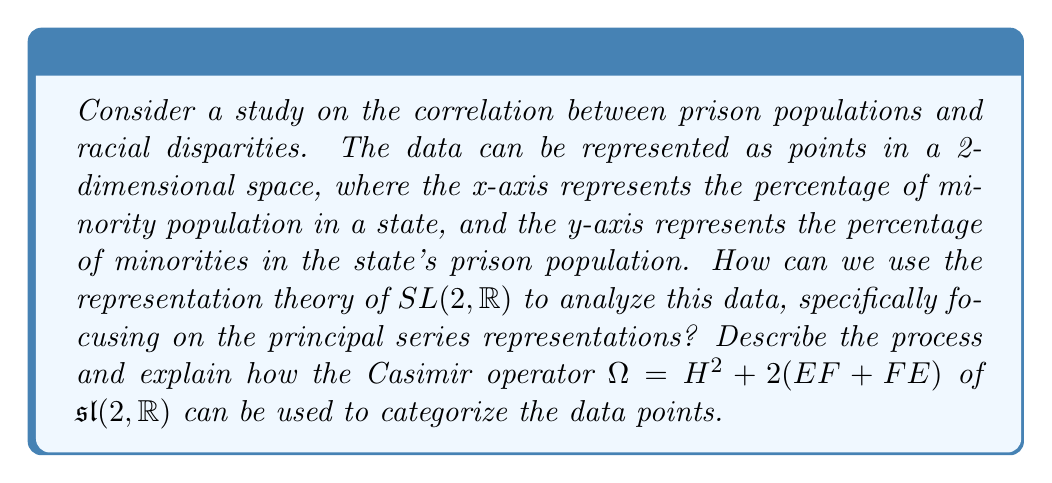Can you solve this math problem? To analyze this socioeconomic data using the representation theory of $SL(2,\mathbb{R})$, we can follow these steps:

1) First, we need to understand that $SL(2,\mathbb{R})$ acts on the upper half-plane model of hyperbolic space $\mathbb{H}^2 = \{z \in \mathbb{C} : \text{Im}(z) > 0\}$ via Möbius transformations:

   $$\begin{pmatrix} a & b \\ c & d \end{pmatrix} \cdot z = \frac{az + b}{cz + d}$$

2) We can map our data points $(x, y)$ to the upper half-plane using the transformation:

   $$z = x + iy$$

3) The principal series representations of $SL(2,\mathbb{R})$ are parameterized by a complex number $s$. For each $s \in \mathbb{C}$, we have a representation $\pi_s$ acting on functions on the real line as:

   $$(\pi_s(g)f)(x) = |cx+d|^{-2s}f(\frac{ax+b}{cx+d})$$

   where $g = \begin{pmatrix} a & b \\ c & d \end{pmatrix} \in SL(2,\mathbb{R})$.

4) The Casimir operator $\Omega = H^2 + 2(EF + FE)$ acts on these representations as a scalar multiple of the identity:

   $$\Omega = s(1-s)I$$

5) To categorize our data points, we can associate each point with a value of $s$. One way to do this is to use the hyperbolic distance $d(z,i)$ from the point $z$ to $i$ in the upper half-plane:

   $$s = \frac{1}{2} + ir, \text{ where } r = \frac{d(z,i)}{2}$$

6) The hyperbolic distance can be calculated using:

   $$d(z,i) = \text{arcosh}(1 + \frac{|z-i|^2}{2\text{Im}(z)})$$

7) Now, for each data point, we have an associated $s$ value, which determines a principal series representation. The Casimir operator eigenvalue $s(1-s)$ for this representation gives us a way to categorize the data points.

8) Points with similar $s$ values (and thus similar Casimir eigenvalues) can be grouped together, potentially revealing patterns in the socioeconomic data.

This approach allows us to use the rich structure of $SL(2,\mathbb{R})$ representations to analyze and categorize our socioeconomic data in a mathematically sophisticated way.
Answer: The process to analyze the data using $SL(2,\mathbb{R})$ representation theory involves:
1) Mapping data points to the upper half-plane
2) Associating each point with a principal series representation parameterized by $s = \frac{1}{2} + ir$
3) Calculating $r$ using the hyperbolic distance: $r = \frac{1}{2}\text{arcosh}(1 + \frac{|z-i|^2}{2\text{Im}(z)})$
4) Categorizing points based on the Casimir operator eigenvalue $s(1-s) = \frac{1}{4} + r^2$

This allows for a sophisticated mathematical categorization of socioeconomic data points based on their associated $SL(2,\mathbb{R})$ representations. 